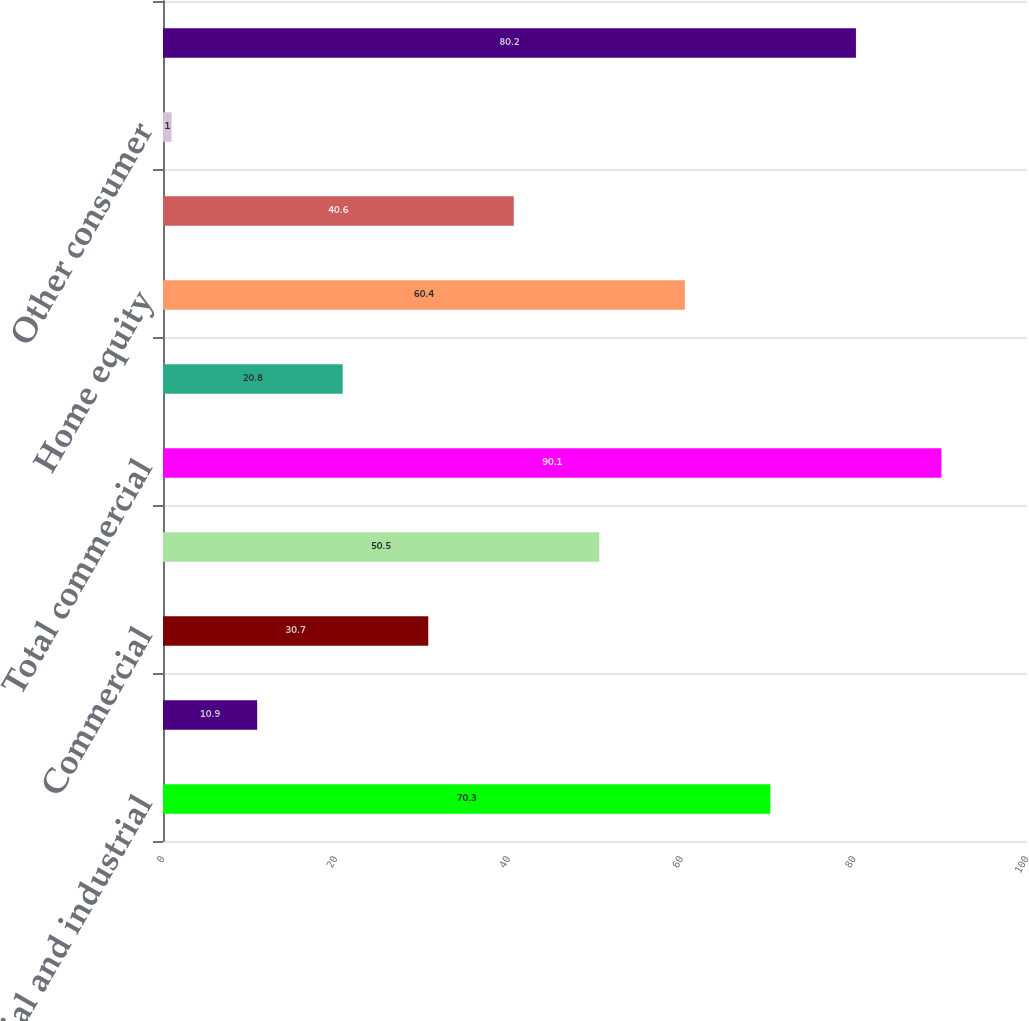<chart> <loc_0><loc_0><loc_500><loc_500><bar_chart><fcel>Commercial and industrial<fcel>Construction<fcel>Commercial<fcel>Total commercial real estate<fcel>Total commercial<fcel>Automobile<fcel>Home equity<fcel>Residential mortgage<fcel>Other consumer<fcel>Total consumer<nl><fcel>70.3<fcel>10.9<fcel>30.7<fcel>50.5<fcel>90.1<fcel>20.8<fcel>60.4<fcel>40.6<fcel>1<fcel>80.2<nl></chart> 